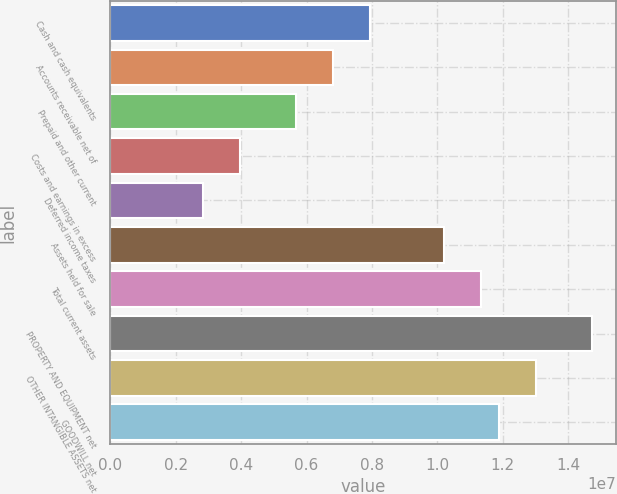Convert chart to OTSL. <chart><loc_0><loc_0><loc_500><loc_500><bar_chart><fcel>Cash and cash equivalents<fcel>Accounts receivable net of<fcel>Prepaid and other current<fcel>Costs and earnings in excess<fcel>Deferred income taxes<fcel>Assets held for sale<fcel>Total current assets<fcel>PROPERTY AND EQUIPMENT net<fcel>OTHER INTANGIBLE ASSETS net<fcel>GOODWILL net<nl><fcel>7.92708e+06<fcel>6.79464e+06<fcel>5.6622e+06<fcel>3.96355e+06<fcel>2.83111e+06<fcel>1.01919e+07<fcel>1.13244e+07<fcel>1.47217e+07<fcel>1.3023e+07<fcel>1.18906e+07<nl></chart> 